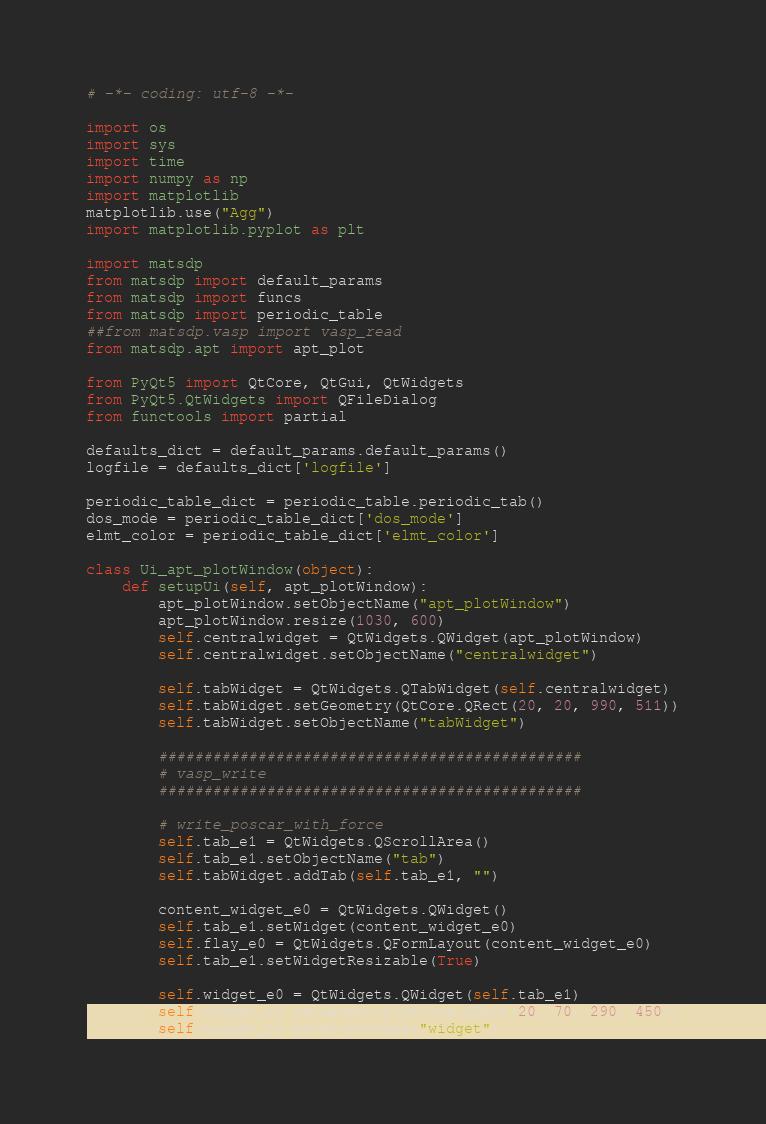Convert code to text. <code><loc_0><loc_0><loc_500><loc_500><_Python_># -*- coding: utf-8 -*-

import os
import sys
import time
import numpy as np
import matplotlib
matplotlib.use("Agg")    
import matplotlib.pyplot as plt

import matsdp
from matsdp import default_params
from matsdp import funcs
from matsdp import periodic_table
##from matsdp.vasp import vasp_read
from matsdp.apt import apt_plot

from PyQt5 import QtCore, QtGui, QtWidgets
from PyQt5.QtWidgets import QFileDialog
from functools import partial

defaults_dict = default_params.default_params()
logfile = defaults_dict['logfile']

periodic_table_dict = periodic_table.periodic_tab()
dos_mode = periodic_table_dict['dos_mode']
elmt_color = periodic_table_dict['elmt_color']

class Ui_apt_plotWindow(object):
    def setupUi(self, apt_plotWindow):
        apt_plotWindow.setObjectName("apt_plotWindow")
        apt_plotWindow.resize(1030, 600)
        self.centralwidget = QtWidgets.QWidget(apt_plotWindow)
        self.centralwidget.setObjectName("centralwidget")
        
        self.tabWidget = QtWidgets.QTabWidget(self.centralwidget)
        self.tabWidget.setGeometry(QtCore.QRect(20, 20, 990, 511))
        self.tabWidget.setObjectName("tabWidget")

        ###############################################
        # vasp_write
        ###############################################

        # write_poscar_with_force
        self.tab_e1 = QtWidgets.QScrollArea()
        self.tab_e1.setObjectName("tab")
        self.tabWidget.addTab(self.tab_e1, "")
        
        content_widget_e0 = QtWidgets.QWidget()
        self.tab_e1.setWidget(content_widget_e0)
        self.flay_e0 = QtWidgets.QFormLayout(content_widget_e0)
        self.tab_e1.setWidgetResizable(True)

        self.widget_e0 = QtWidgets.QWidget(self.tab_e1)
        self.widget_e0.setGeometry(QtCore.QRect(20, 70, 290, 450))
        self.widget_e0.setObjectName("widget")</code> 